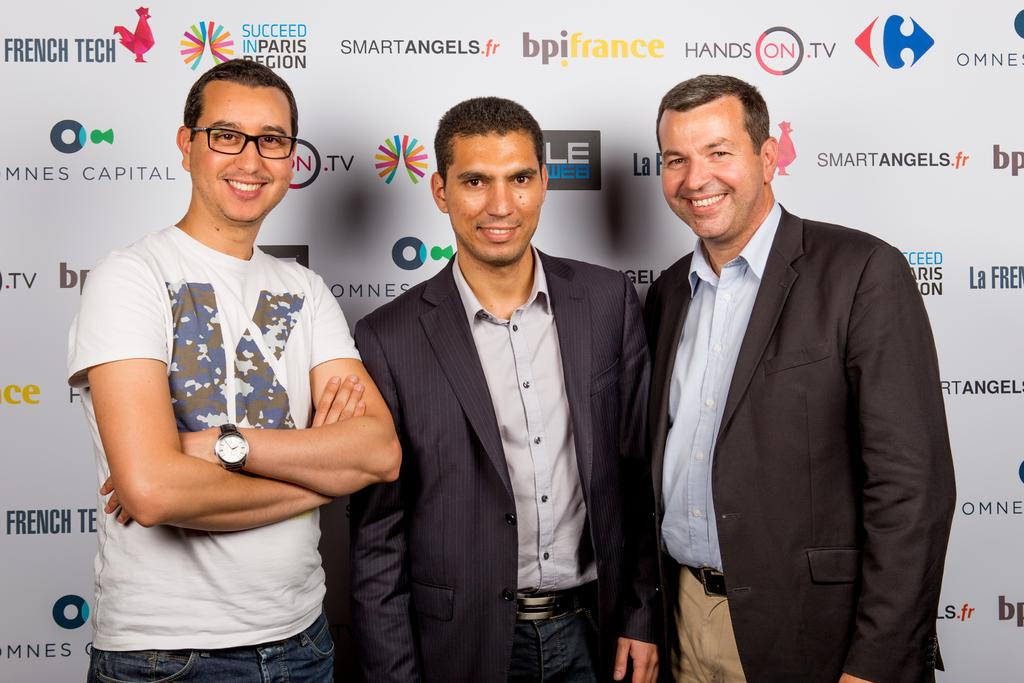How many people are in the image? There are three men standing in the image. What expressions do the men have? The men are smiling in the image. What can be seen in the background of the image? There is a board in the background of the image. What is on the board? There are logos and text on the board. What type of silk fabric is draped over the men's legs in the image? There is no silk fabric or any fabric draped over the men's legs in the image. What type of sign is visible in the image? There is no sign visible in the image; only a board with logos and text is present. 